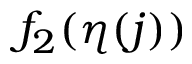<formula> <loc_0><loc_0><loc_500><loc_500>f _ { 2 } ( \eta ( j ) )</formula> 